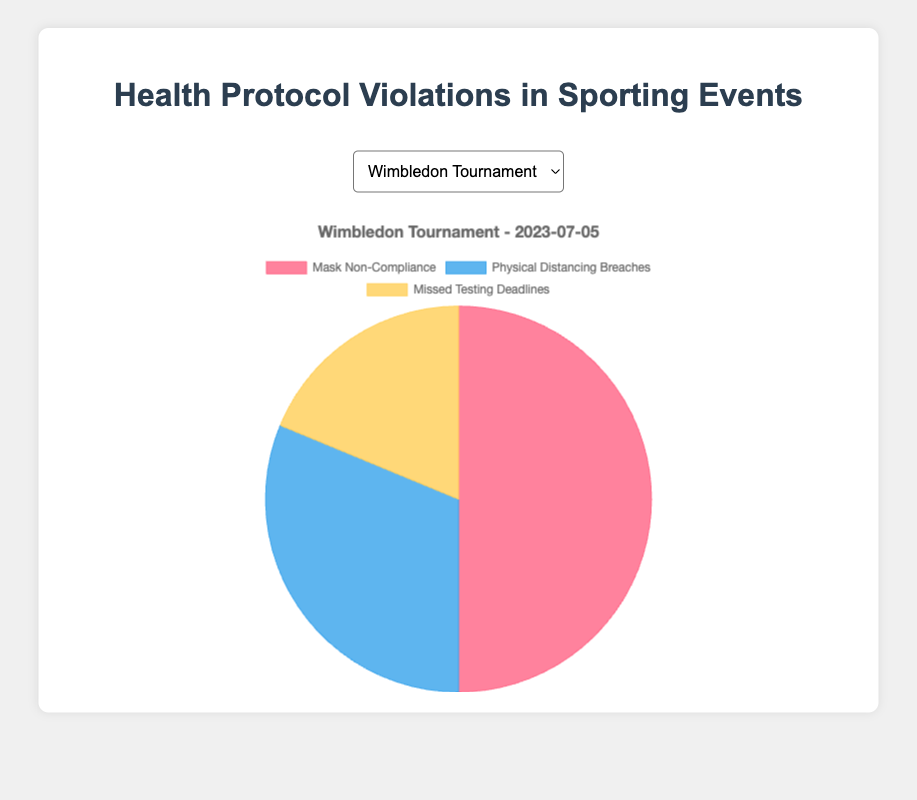What is the most common type of health protocol violation at the Wimbledon Tournament? By examining the data, we can see that "mask_non_compliance" has 40 instances, "physical_distancing_breaches" has 25 instances, and "missed_testing_deadlines" has 15 instances. "Mask non-compliance" has the highest count here.
Answer: Mask non-compliance How do the instances of missed testing deadlines compare between the Super Bowl and Tokyo Marathon? The "missed_testing_deadlines" count for the Super Bowl is 30, while for the Tokyo Marathon it is 5. 30 is greater than 5, indicating there are more instances of missed testing deadlines at the Super Bowl.
Answer: Super Bowl has more What is the sum of physical distancing breaches for the Tour de France and Tokyo Marathon? The data shows 20 instances for the Tour de France and 40 instances for the Tokyo Marathon. Adding these together: 20 + 40 = 60.
Answer: 60 Which event has the fewest violations for mask non-compliance? Looking at the data, the counts for mask non-compliance are: Wimbledon (40), US Open (55), Tour de France (30), Tokyo Marathon (45), and Super Bowl (60). Therefore, the Tour de France has the lowest count with 30.
Answer: Tour de France Which type of violation is represented by the blue color in the chart? Observing the provided color assignments for the chart: ‘Mask Non-Compliance’ is red, ‘Physical Distancing Breaches’ is blue, and ‘Missed Testing Deadlines’ is yellow. Therefore, the blue color represents Physical Distancing Breaches.
Answer: Physical Distancing Breaches What is the average number of missed testing deadlines across all events? First add the missed testing deadlines from all events: 15 (Wimbledon) + 20 (US Open) + 10 (Tour de France) + 5 (Tokyo Marathon) + 30 (Super Bowl) = 80. There are 5 events, so the average is 80 / 5 = 16.
Answer: 16 